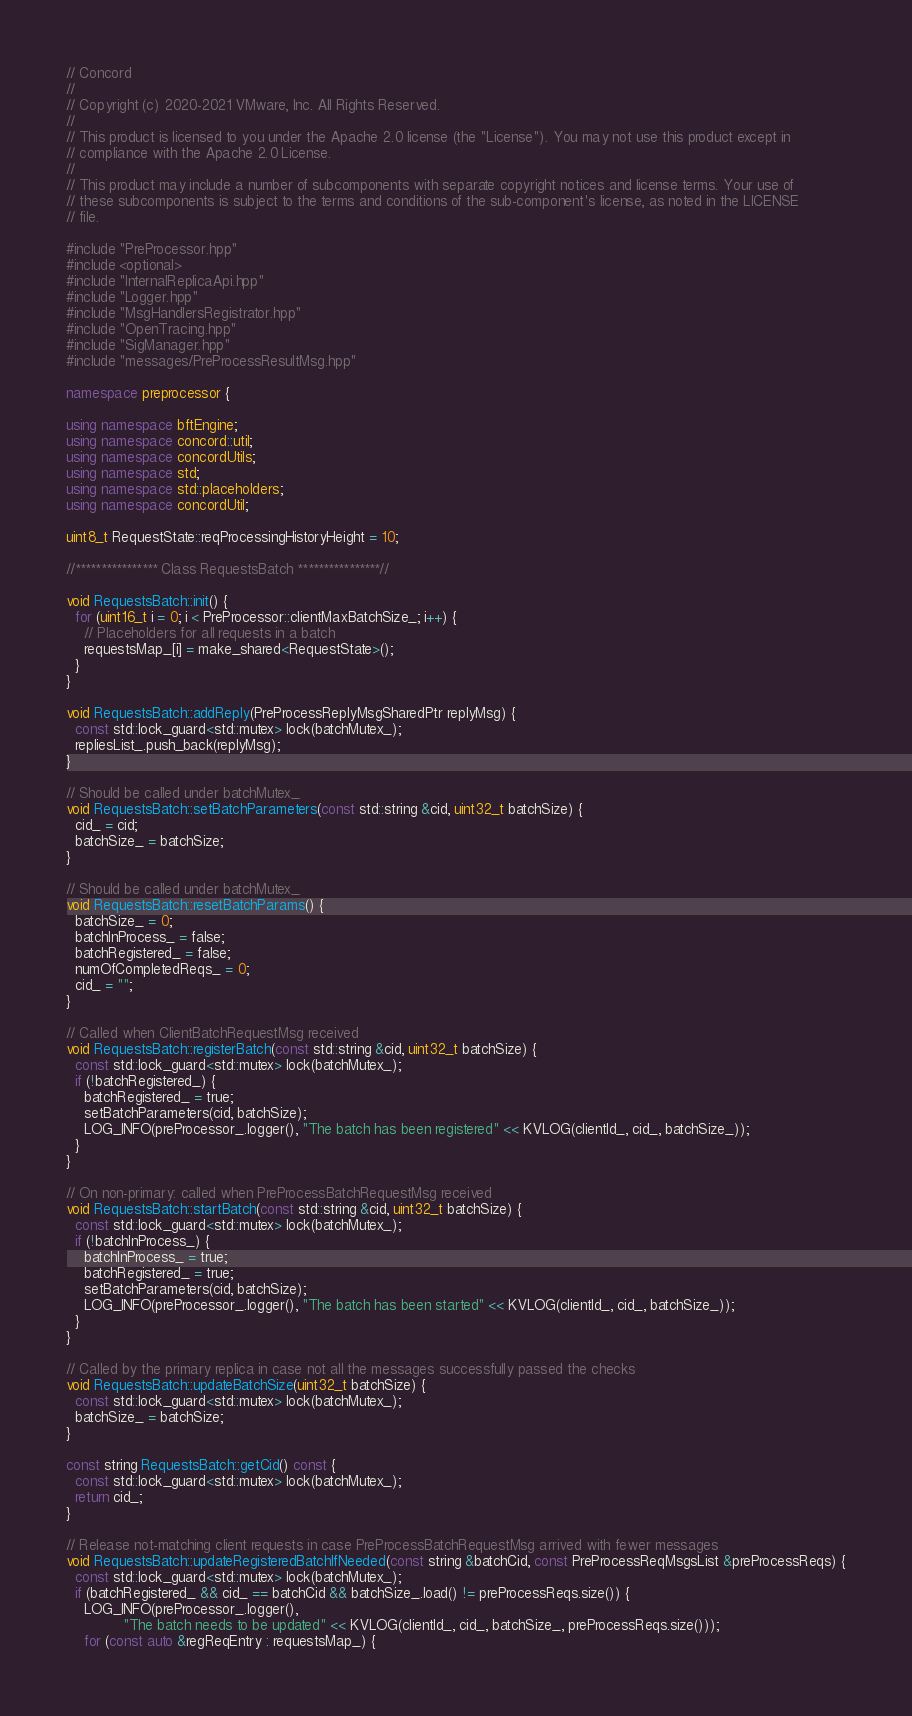<code> <loc_0><loc_0><loc_500><loc_500><_C++_>// Concord
//
// Copyright (c) 2020-2021 VMware, Inc. All Rights Reserved.
//
// This product is licensed to you under the Apache 2.0 license (the "License"). You may not use this product except in
// compliance with the Apache 2.0 License.
//
// This product may include a number of subcomponents with separate copyright notices and license terms. Your use of
// these subcomponents is subject to the terms and conditions of the sub-component's license, as noted in the LICENSE
// file.

#include "PreProcessor.hpp"
#include <optional>
#include "InternalReplicaApi.hpp"
#include "Logger.hpp"
#include "MsgHandlersRegistrator.hpp"
#include "OpenTracing.hpp"
#include "SigManager.hpp"
#include "messages/PreProcessResultMsg.hpp"

namespace preprocessor {

using namespace bftEngine;
using namespace concord::util;
using namespace concordUtils;
using namespace std;
using namespace std::placeholders;
using namespace concordUtil;

uint8_t RequestState::reqProcessingHistoryHeight = 10;

//**************** Class RequestsBatch ****************//

void RequestsBatch::init() {
  for (uint16_t i = 0; i < PreProcessor::clientMaxBatchSize_; i++) {
    // Placeholders for all requests in a batch
    requestsMap_[i] = make_shared<RequestState>();
  }
}

void RequestsBatch::addReply(PreProcessReplyMsgSharedPtr replyMsg) {
  const std::lock_guard<std::mutex> lock(batchMutex_);
  repliesList_.push_back(replyMsg);
}

// Should be called under batchMutex_
void RequestsBatch::setBatchParameters(const std::string &cid, uint32_t batchSize) {
  cid_ = cid;
  batchSize_ = batchSize;
}

// Should be called under batchMutex_
void RequestsBatch::resetBatchParams() {
  batchSize_ = 0;
  batchInProcess_ = false;
  batchRegistered_ = false;
  numOfCompletedReqs_ = 0;
  cid_ = "";
}

// Called when ClientBatchRequestMsg received
void RequestsBatch::registerBatch(const std::string &cid, uint32_t batchSize) {
  const std::lock_guard<std::mutex> lock(batchMutex_);
  if (!batchRegistered_) {
    batchRegistered_ = true;
    setBatchParameters(cid, batchSize);
    LOG_INFO(preProcessor_.logger(), "The batch has been registered" << KVLOG(clientId_, cid_, batchSize_));
  }
}

// On non-primary: called when PreProcessBatchRequestMsg received
void RequestsBatch::startBatch(const std::string &cid, uint32_t batchSize) {
  const std::lock_guard<std::mutex> lock(batchMutex_);
  if (!batchInProcess_) {
    batchInProcess_ = true;
    batchRegistered_ = true;
    setBatchParameters(cid, batchSize);
    LOG_INFO(preProcessor_.logger(), "The batch has been started" << KVLOG(clientId_, cid_, batchSize_));
  }
}

// Called by the primary replica in case not all the messages successfully passed the checks
void RequestsBatch::updateBatchSize(uint32_t batchSize) {
  const std::lock_guard<std::mutex> lock(batchMutex_);
  batchSize_ = batchSize;
}

const string RequestsBatch::getCid() const {
  const std::lock_guard<std::mutex> lock(batchMutex_);
  return cid_;
}

// Release not-matching client requests in case PreProcessBatchRequestMsg arrived with fewer messages
void RequestsBatch::updateRegisteredBatchIfNeeded(const string &batchCid, const PreProcessReqMsgsList &preProcessReqs) {
  const std::lock_guard<std::mutex> lock(batchMutex_);
  if (batchRegistered_ && cid_ == batchCid && batchSize_.load() != preProcessReqs.size()) {
    LOG_INFO(preProcessor_.logger(),
             "The batch needs to be updated" << KVLOG(clientId_, cid_, batchSize_, preProcessReqs.size()));
    for (const auto &regReqEntry : requestsMap_) {</code> 